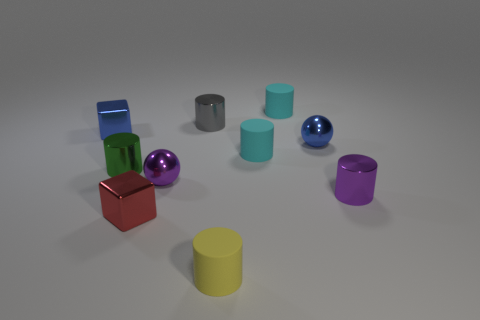Does the yellow object have the same size as the purple metal ball? While the yellow object appears similar in height to the purple metal ball, differences in shape can make direct size comparisons challenging without additional context or precise measurements. 